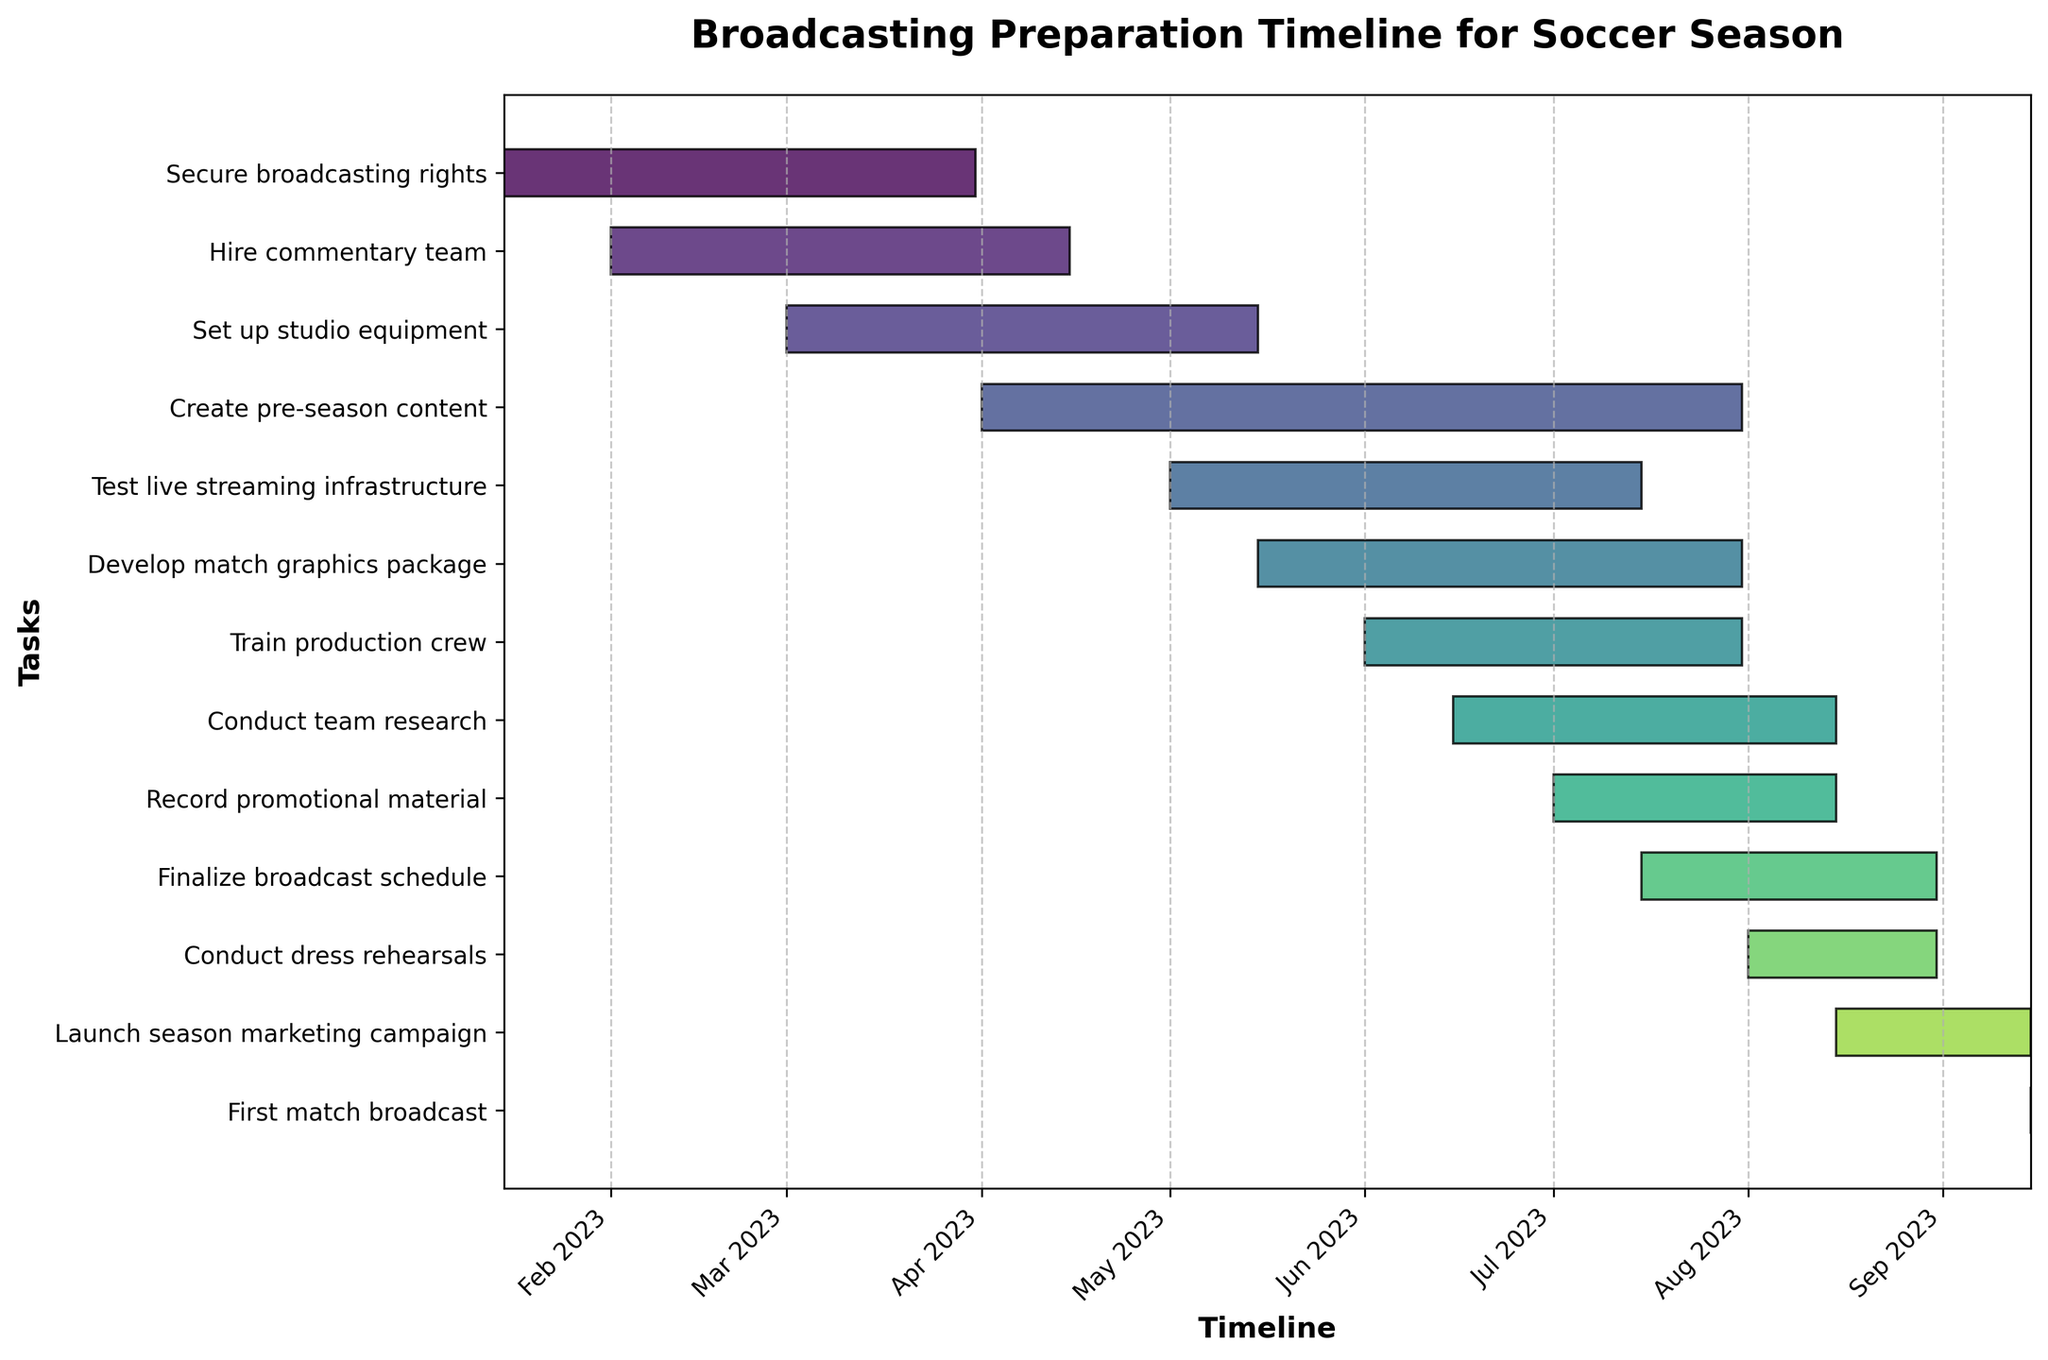what’s the title of the figure? The title is always prominently displayed at the top of the figure. In this case, it's written in a bold font.
Answer: Broadcasting Preparation Timeline for Soccer Season what is the first task and its duration? The first task listed in the Gantt chart is 'Secure broadcasting rights,' and its duration is determined from the start date (2023-01-15) to the end date (2023-03-31). To find the duration, count the number of days between these dates.
Answer: 75 days which task takes the longest time to complete? By visually comparing the horizontal bars, the longest bar corresponds to the 'Create pre-season content' task. Checking the dates, it runs from 2023-04-01 to 2023-07-31.
Answer: Create pre-season content What tasks are completed by the end of July 2023? To determine which tasks are completed by the end of July, check the end dates of all tasks. Tasks like 'Secure broadcasting rights,' 'Hire commentary team,' 'Set up studio equipment,' 'Create pre-season content,' 'Test live streaming infrastructure,' 'Develop match graphics package,' and 'Train production crew' all conclude by 2023-07-31.
Answer: Secure broadcasting rights, Hire commentary team, Set up studio equipment, Create pre-season content, Test live streaming infrastructure, Develop match graphics package, Train production crew which task overlaps with the 'Test live streaming infrastructure' task? To find tasks overlapping with 'Test live streaming infrastructure,' look for tasks that span any date range within 2023-05-01 to 2023-07-15. Overlapping tasks are 'Create pre-season content,' 'Develop match graphics package,' and 'Train production crew.'
Answer: Create pre-season content, Develop match graphics package, Train production crew how many tasks are initiated in June 2023? By checking the start dates of each task, identify those that begin in June 2023. These tasks are 'Train production crew' and 'Conduct team research.'
Answer: 2 tasks when does the 'Conduct dress rehearsals' task occur, and for how long? The 'Conduct dress rehearsals' task starts and ends in the month of August. It runs from 2023-08-01 to 2023-08-31, making its duration 30 days.
Answer: August 2023, 30 days are there any tasks that end on the same day as 'First match broadcast?' The 'First match broadcast' occurs on 2023-09-15. Checking for tasks that end on this same date shows 'Launch season marketing campaign' ends on 2023-09-15.
Answer: Launch season marketing campaign what’s the color representation for 'Secure broadcasting rights?' The Gantt chart typically uses a color gradient to signify different tasks. The color representing 'Secure broadcasting rights' is likely a shade of greenish due to the position in a color spectrum such as viridis.
Answer: shade of greenish 